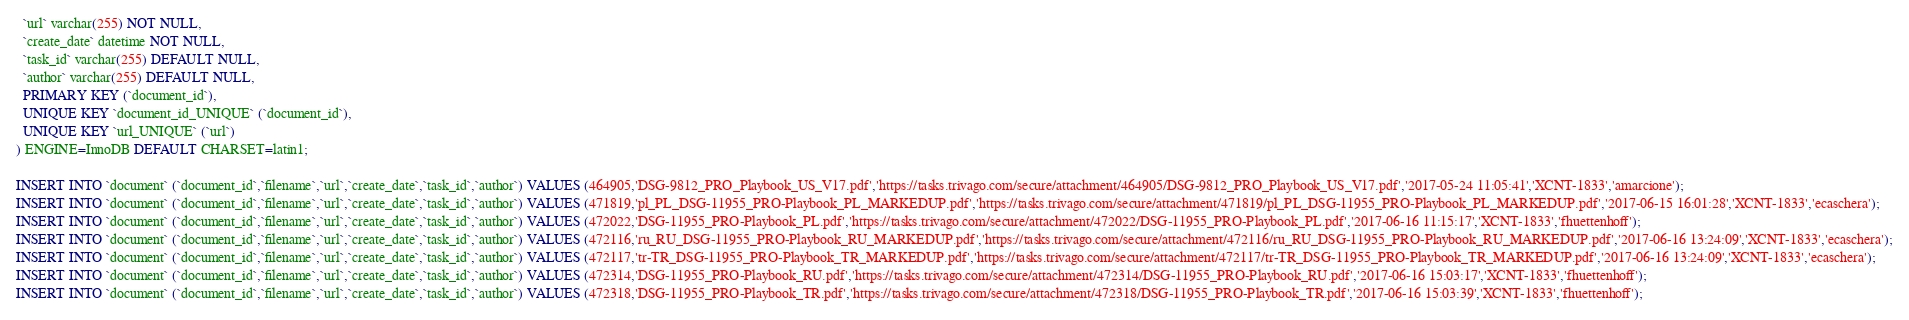Convert code to text. <code><loc_0><loc_0><loc_500><loc_500><_SQL_>  `url` varchar(255) NOT NULL,
  `create_date` datetime NOT NULL,
  `task_id` varchar(255) DEFAULT NULL,
  `author` varchar(255) DEFAULT NULL,
  PRIMARY KEY (`document_id`),
  UNIQUE KEY `document_id_UNIQUE` (`document_id`),
  UNIQUE KEY `url_UNIQUE` (`url`)
) ENGINE=InnoDB DEFAULT CHARSET=latin1;

INSERT INTO `document` (`document_id`,`filename`,`url`,`create_date`,`task_id`,`author`) VALUES (464905,'DSG-9812_PRO_Playbook_US_V17.pdf','https://tasks.trivago.com/secure/attachment/464905/DSG-9812_PRO_Playbook_US_V17.pdf','2017-05-24 11:05:41','XCNT-1833','amarcione');
INSERT INTO `document` (`document_id`,`filename`,`url`,`create_date`,`task_id`,`author`) VALUES (471819,'pl_PL_DSG-11955_PRO-Playbook_PL_MARKEDUP.pdf','https://tasks.trivago.com/secure/attachment/471819/pl_PL_DSG-11955_PRO-Playbook_PL_MARKEDUP.pdf','2017-06-15 16:01:28','XCNT-1833','ecaschera');
INSERT INTO `document` (`document_id`,`filename`,`url`,`create_date`,`task_id`,`author`) VALUES (472022,'DSG-11955_PRO-Playbook_PL.pdf','https://tasks.trivago.com/secure/attachment/472022/DSG-11955_PRO-Playbook_PL.pdf','2017-06-16 11:15:17','XCNT-1833','fhuettenhoff');
INSERT INTO `document` (`document_id`,`filename`,`url`,`create_date`,`task_id`,`author`) VALUES (472116,'ru_RU_DSG-11955_PRO-Playbook_RU_MARKEDUP.pdf','https://tasks.trivago.com/secure/attachment/472116/ru_RU_DSG-11955_PRO-Playbook_RU_MARKEDUP.pdf','2017-06-16 13:24:09','XCNT-1833','ecaschera');
INSERT INTO `document` (`document_id`,`filename`,`url`,`create_date`,`task_id`,`author`) VALUES (472117,'tr-TR_DSG-11955_PRO-Playbook_TR_MARKEDUP.pdf','https://tasks.trivago.com/secure/attachment/472117/tr-TR_DSG-11955_PRO-Playbook_TR_MARKEDUP.pdf','2017-06-16 13:24:09','XCNT-1833','ecaschera');
INSERT INTO `document` (`document_id`,`filename`,`url`,`create_date`,`task_id`,`author`) VALUES (472314,'DSG-11955_PRO-Playbook_RU.pdf','https://tasks.trivago.com/secure/attachment/472314/DSG-11955_PRO-Playbook_RU.pdf','2017-06-16 15:03:17','XCNT-1833','fhuettenhoff');
INSERT INTO `document` (`document_id`,`filename`,`url`,`create_date`,`task_id`,`author`) VALUES (472318,'DSG-11955_PRO-Playbook_TR.pdf','https://tasks.trivago.com/secure/attachment/472318/DSG-11955_PRO-Playbook_TR.pdf','2017-06-16 15:03:39','XCNT-1833','fhuettenhoff');</code> 